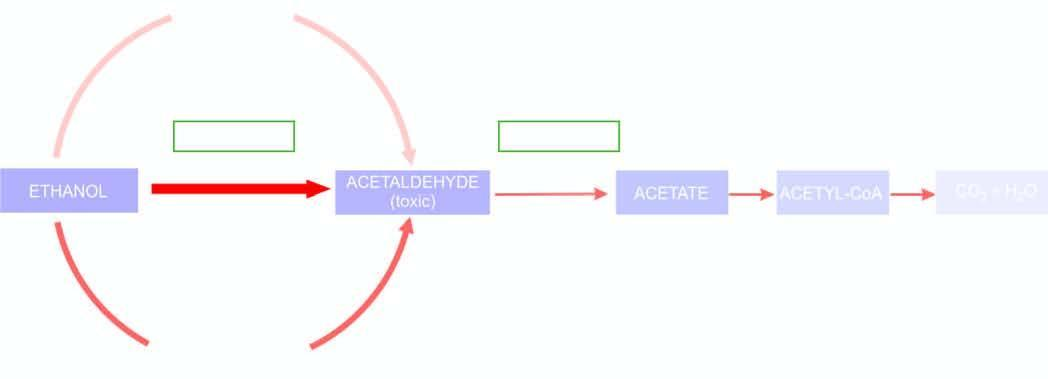what corresponds to extent of metabolic pathway followed adh = alcohol dehydrogenase ; aldh or acdh = hepatic acetaldehyde dehydrogenase ; nad = nicotinamide adenine dinucleotide ; nadh = reduced nad?
Answer the question using a single word or phrase. Thickness and intensity of colour of on left side of figure 